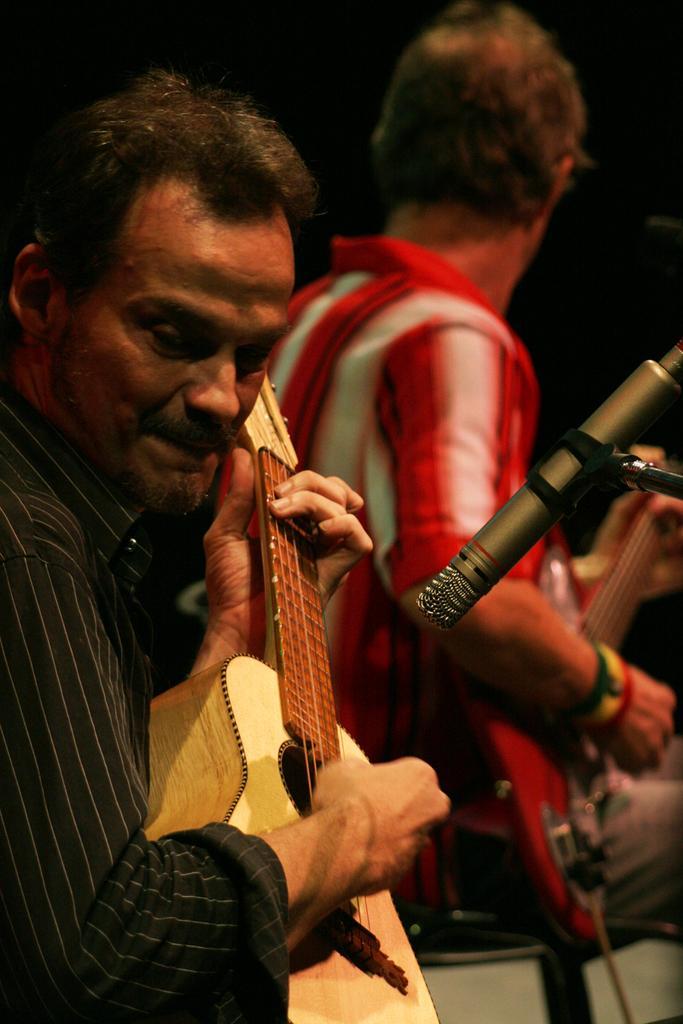Can you describe this image briefly? In this picture there are two persons. One is holding the guitar with his left and playing the guitar with his right hand, and there is a another person standing behind and he is also playing the guitar there is a microphone in front of them 